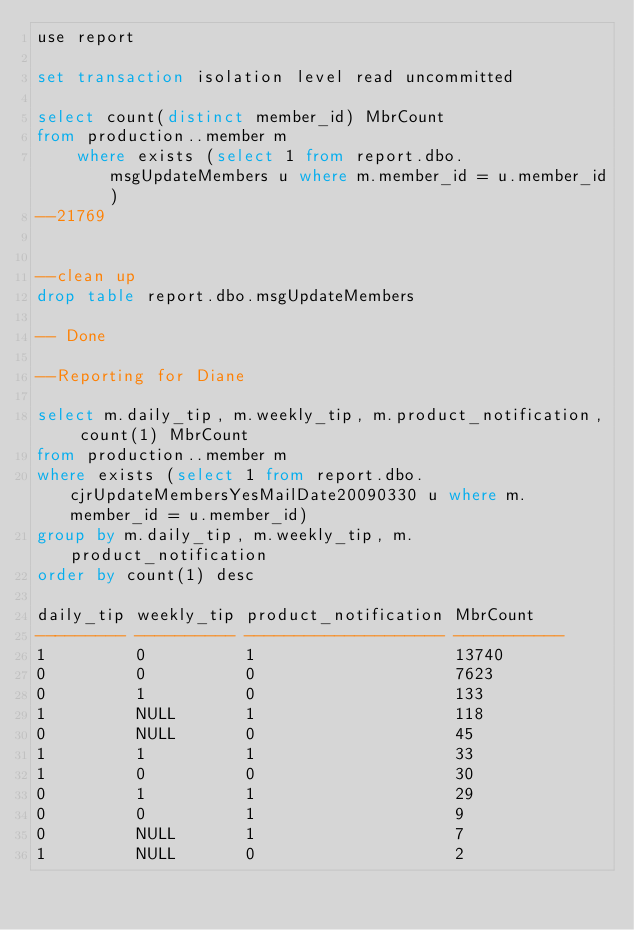Convert code to text. <code><loc_0><loc_0><loc_500><loc_500><_SQL_>use report

set transaction isolation level read uncommitted

select count(distinct member_id) MbrCount
from production..member m
		where exists (select 1 from report.dbo.msgUpdateMembers u where m.member_id = u.member_id)
--21769


--clean up
drop table report.dbo.msgUpdateMembers

-- Done

--Reporting for Diane

select m.daily_tip, m.weekly_tip, m.product_notification, count(1) MbrCount
from production..member m
where exists (select 1 from report.dbo.cjrUpdateMembersYesMailDate20090330 u where m.member_id = u.member_id)
group by m.daily_tip, m.weekly_tip, m.product_notification
order by count(1) desc

daily_tip weekly_tip product_notification MbrCount
--------- ---------- -------------------- -----------
1         0          1                    13740
0         0          0                    7623
0         1          0                    133
1         NULL       1                    118
0         NULL       0                    45
1         1          1                    33
1         0          0                    30
0         1          1                    29
0         0          1                    9
0         NULL       1                    7
1         NULL       0                    2





</code> 